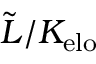Convert formula to latex. <formula><loc_0><loc_0><loc_500><loc_500>\tilde { L } / K _ { e l o }</formula> 